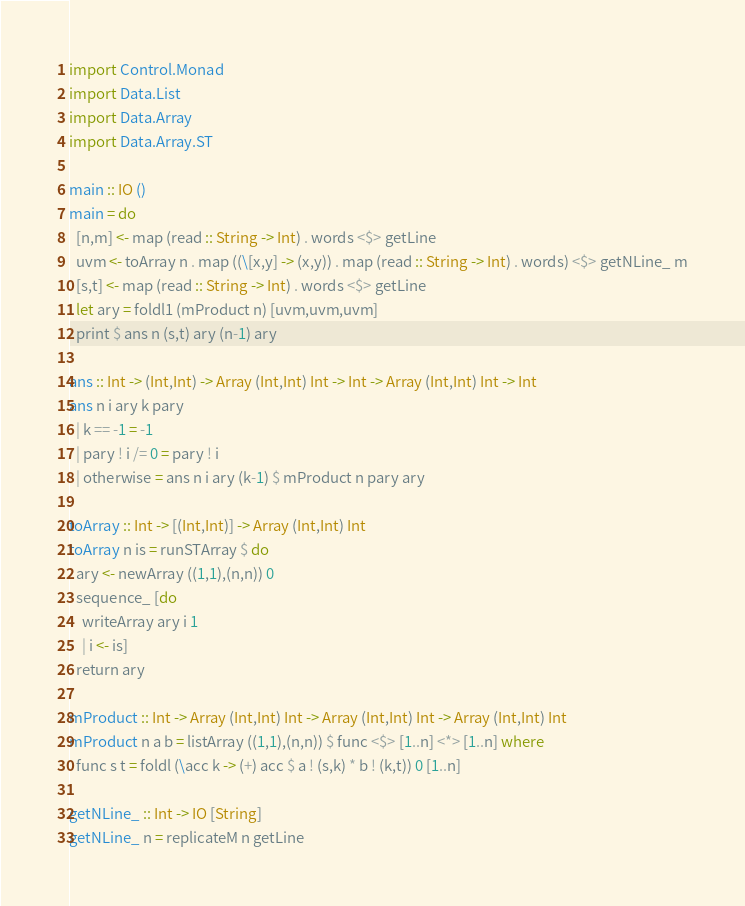<code> <loc_0><loc_0><loc_500><loc_500><_Haskell_>import Control.Monad
import Data.List
import Data.Array
import Data.Array.ST

main :: IO ()
main = do
  [n,m] <- map (read :: String -> Int) . words <$> getLine
  uvm <- toArray n . map ((\[x,y] -> (x,y)) . map (read :: String -> Int) . words) <$> getNLine_ m
  [s,t] <- map (read :: String -> Int) . words <$> getLine
  let ary = foldl1 (mProduct n) [uvm,uvm,uvm]
  print $ ans n (s,t) ary (n-1) ary

ans :: Int -> (Int,Int) -> Array (Int,Int) Int -> Int -> Array (Int,Int) Int -> Int
ans n i ary k pary
  | k == -1 = -1
  | pary ! i /= 0 = pary ! i
  | otherwise = ans n i ary (k-1) $ mProduct n pary ary

toArray :: Int -> [(Int,Int)] -> Array (Int,Int) Int
toArray n is = runSTArray $ do
  ary <- newArray ((1,1),(n,n)) 0
  sequence_ [do
    writeArray ary i 1
    | i <- is]
  return ary

mProduct :: Int -> Array (Int,Int) Int -> Array (Int,Int) Int -> Array (Int,Int) Int
mProduct n a b = listArray ((1,1),(n,n)) $ func <$> [1..n] <*> [1..n] where
  func s t = foldl (\acc k -> (+) acc $ a ! (s,k) * b ! (k,t)) 0 [1..n]

getNLine_ :: Int -> IO [String]
getNLine_ n = replicateM n getLine
</code> 